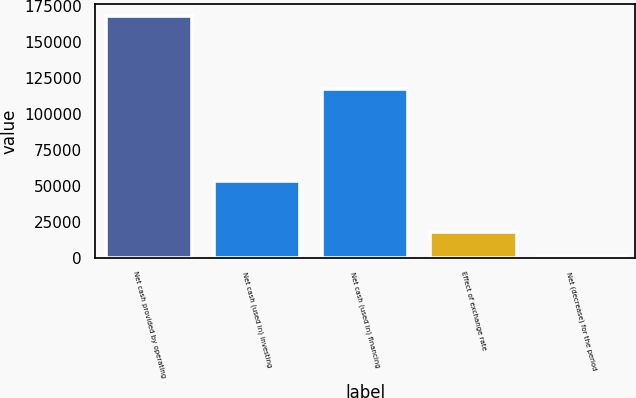<chart> <loc_0><loc_0><loc_500><loc_500><bar_chart><fcel>Net cash provided by operating<fcel>Net cash (used in) investing<fcel>Net cash (used in) financing<fcel>Effect of exchange rate<fcel>Net (decrease) for the period<nl><fcel>168035<fcel>53653<fcel>117068<fcel>17909.6<fcel>1229<nl></chart> 